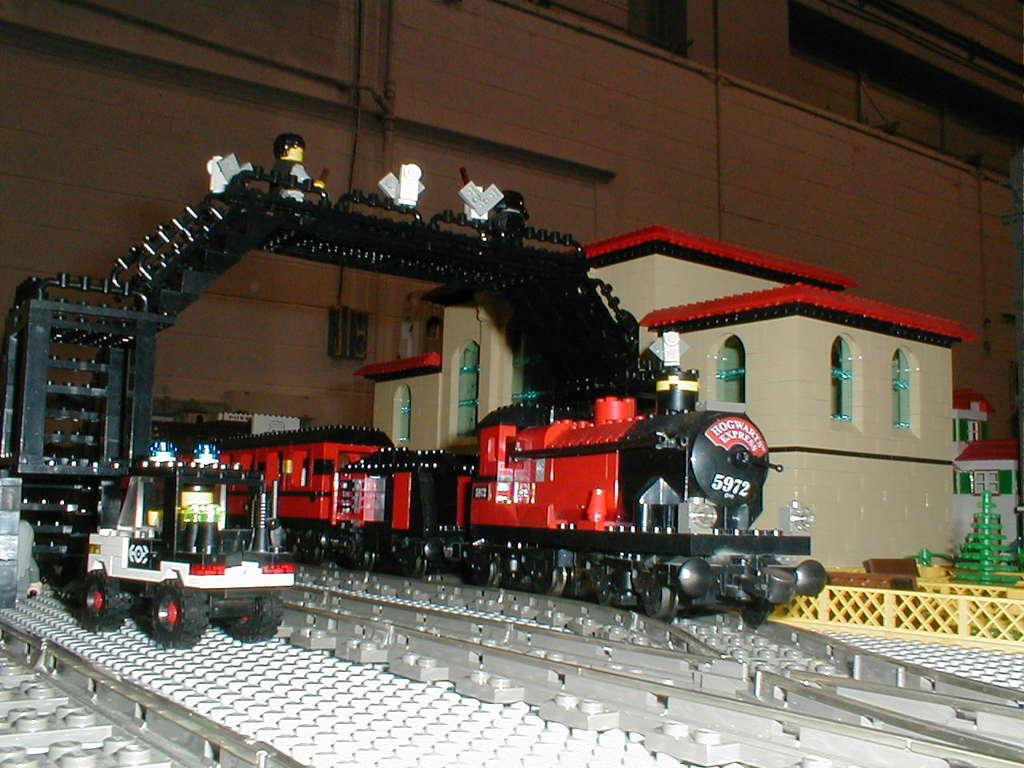What type of vehicle is shown in the image? There is a train on the track in the image. What is the train doing in the image? The train is on the track in the image. What other structures are present in the image? There is a house and a wall in the background of the image. Are there any unique features on the train? Yes, there are stairs on top of the train in the image. What type of underwear is hanging on the clothesline in the image? There is no clothesline or underwear present in the image. Can you describe the bird perched on the roof of the house in the image? There is no bird present on the roof of the house in the image. 